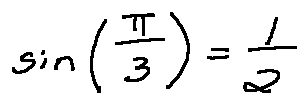<formula> <loc_0><loc_0><loc_500><loc_500>\sin ( \frac { \pi } { 3 } ) = \frac { 1 } { 2 }</formula> 